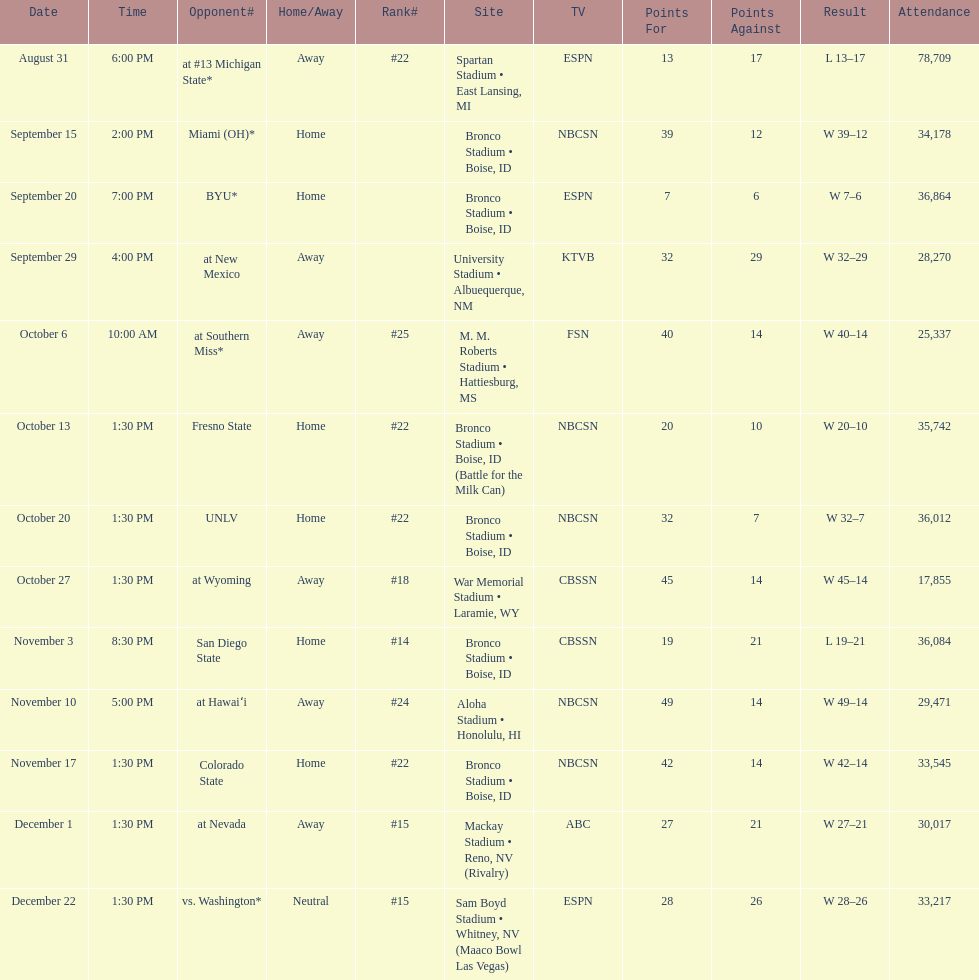Which team has the highest rank among those listed? San Diego State. 